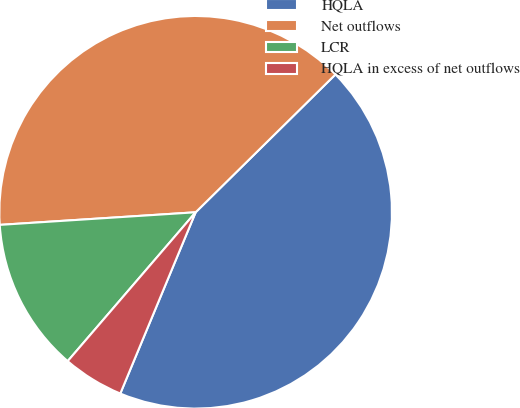<chart> <loc_0><loc_0><loc_500><loc_500><pie_chart><fcel>HQLA<fcel>Net outflows<fcel>LCR<fcel>HQLA in excess of net outflows<nl><fcel>43.66%<fcel>38.64%<fcel>12.68%<fcel>5.03%<nl></chart> 